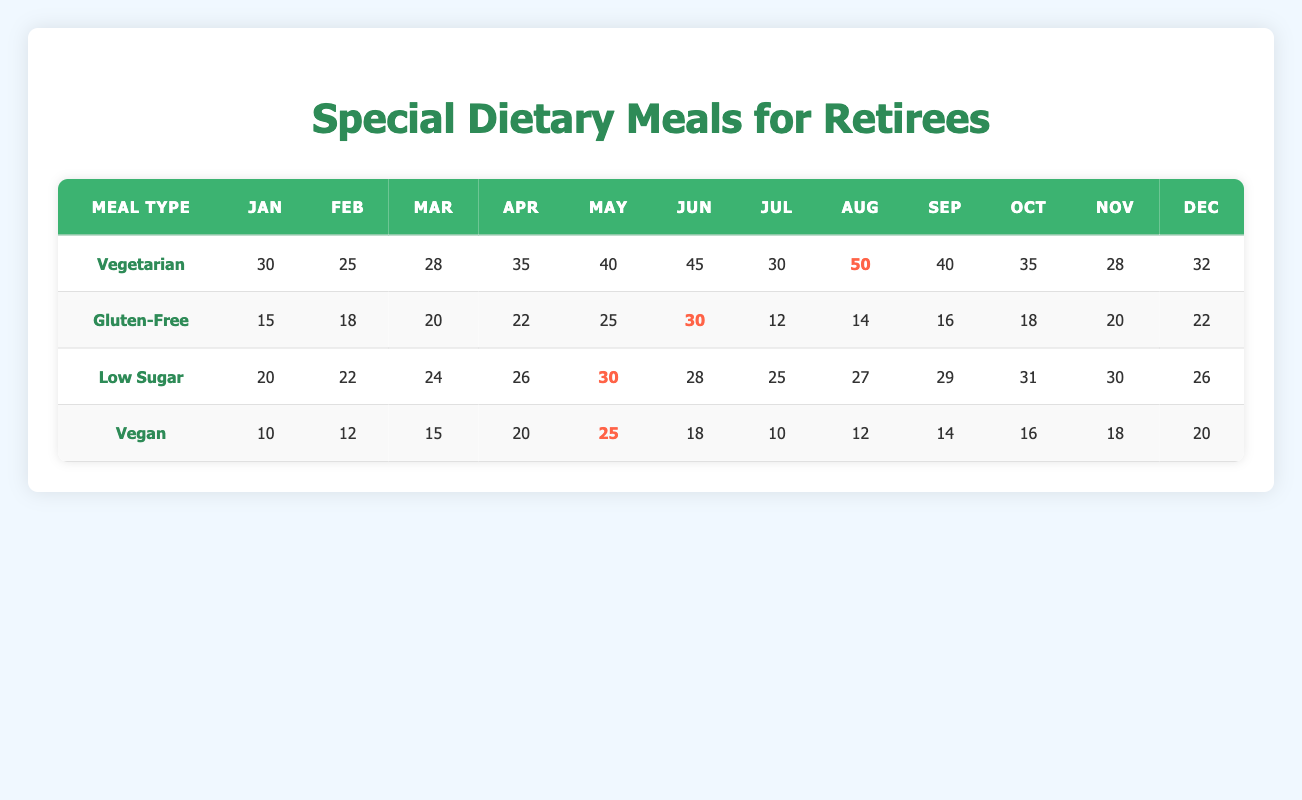What is the total count of Vegetarian meals provided in May? Looking at the row for Vegetarian meals, the value for May is directly listed as 40.
Answer: 40 Which month had the highest Gluten-Free meal offerings? In the Gluten-Free row, the monthly values peak in June with a count of 30, higher than any other month.
Answer: June What is the average number of Vegan meals provided over the year? The Vegan meal counts for each month are summed: (10 + 12 + 15 + 20 + 25 + 18 + 10 + 12 + 14 + 16 + 18 + 20 =  180). There are 12 months, so the average is 180 / 12 = 15.
Answer: 15 Did the count of Low Sugar meals increase or decrease from January to December? Looking at the Low Sugar row, January has 20 meals and December has 26 meals. Since there is an increase from 20 to 26, the answer is an increase.
Answer: Yes Which meal type had the highest total servings over the year? To find the totals, sum each meal type: Vegetarian (30 + 25 + 28 + 35 + 40 + 45 + 30 + 50 + 40 + 35 + 28 + 32 =  425), Gluten-Free (15 + 18 + 20 + 22 + 25 + 30 + 12 + 14 + 16 + 18 + 20 + 22 =  252), Low Sugar (20 + 22 + 24 + 26 + 30 + 28 + 25 + 27 + 29 + 31 + 30 + 26 =  308), Vegan (10 + 12 + 15 + 20 + 25 + 18 + 10 + 12 + 14 + 16 + 18 + 20 =  180). The highest is Vegetarian with 425 meals.
Answer: Vegetarian How many Gluten-Free meals were served in the second quarter (April to June)? Adding the Gluten-Free counts for April (22), May (25), and June (30): 22 + 25 + 30 = 77 meals total in the second quarter.
Answer: 77 